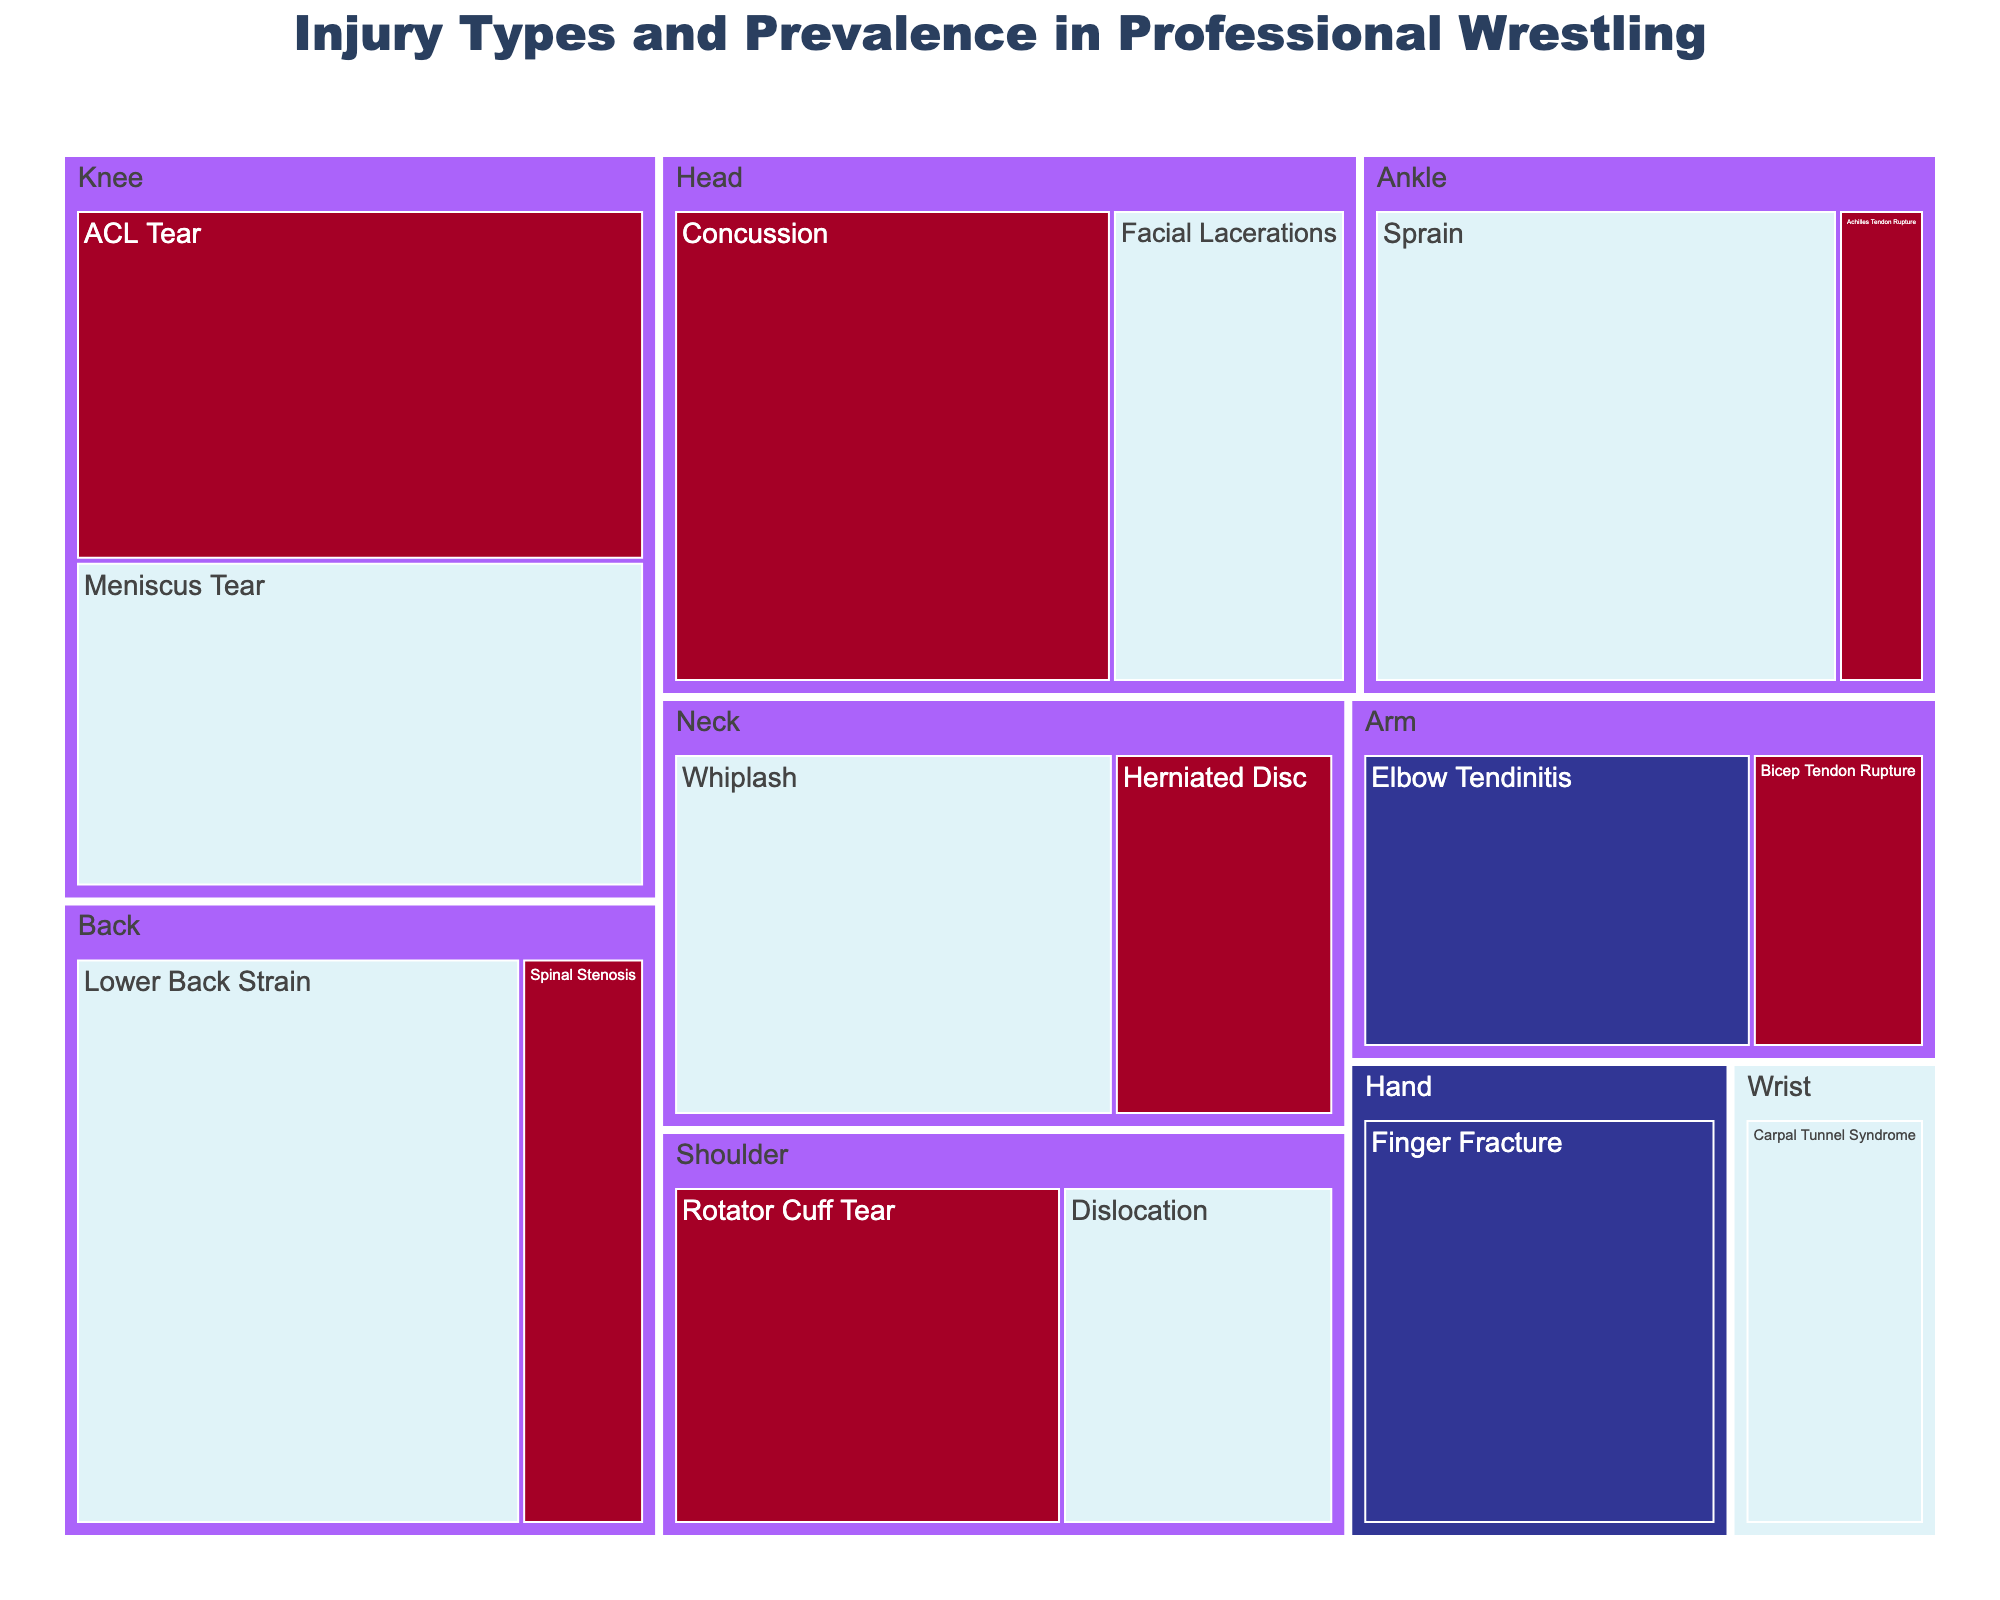How many injury types are associated with the Head? To determine this, we count the unique injury types listed under the Head category. According to the data, the Head body part has two injury types: Concussion and Facial Lacerations.
Answer: 2 Which body part has the highest injury prevalence? To identify this, compare the prevalence values across all body parts. The Back has the highest single injury prevalence with Lower Back Strain at 18.
Answer: Back What is the total prevalence of knee injuries? Add the prevalence values of all knee injuries. The Knee category includes ACL Tear (14) and Meniscus Tear (13). So, 14 + 13 = 27.
Answer: 27 Is there a lower prevalence of Rotator Cuff Tear or ACL Tear? Compare the prevalence values of both injury types. The prevalence of Rotator Cuff Tear is 10, while ACL Tear is 14.
Answer: Rotator Cuff Tear Which severity level is the most common in terms of the number of injury types? Count the number of injury types within each severity level (Low, Medium, High). There are 2 Low, 6 Medium, and 6 High severity injuries. Medium and High are the most common.
Answer: Medium and High What is the total prevalence of high severity injuries? Sum the prevalence of all high severity injuries: Concussion (15), Herniated Disc (6), Rotator Cuff Tear (10), Spinal Stenosis (5), Bicep Tendon Rupture (4), ACL Tear (14), Achilles Tendon Rupture (3). So, 15 + 6 + 10 + 5 + 4 + 14 + 3 = 57.
Answer: 57 Which injury type in the shoulder has a higher prevalence? Compare the prevalence values of Rotator Cuff Tear and Dislocation in the shoulder. Rotator Cuff Tear has a prevalence of 10, while Dislocation is 7. Rotator Cuff Tear is higher.
Answer: Rotator Cuff Tear How many total injury types are listed? To get this count, sum the number of injury types across all body parts. There are 16 injury types listed in the data.
Answer: 16 What is the least prevalent high severity injury? Compare the prevalence values of all high severity injuries and identify the smallest one. Achilles Tendon Rupture has the lowest prevalence with 3.
Answer: Achilles Tendon Rupture Which body part has more injuries, Arm or Hand? Count the number of injury types in the Arm and Hand categories. The Arm has 2 injuries (Bicep Tendon Rupture, Elbow Tendinitis) and Hand has 1 injury (Finger Fracture).
Answer: Arm 